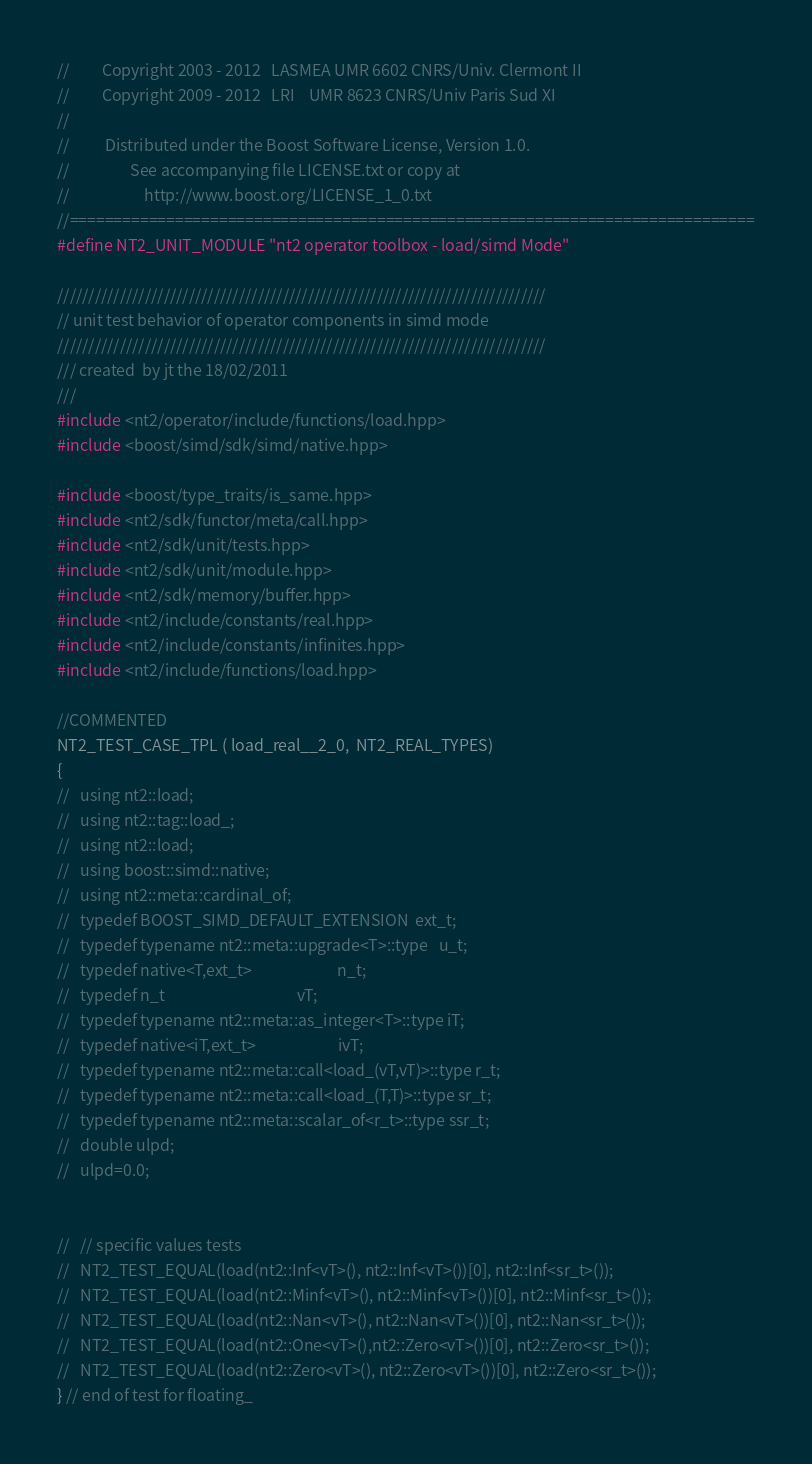<code> <loc_0><loc_0><loc_500><loc_500><_C++_>//         Copyright 2003 - 2012   LASMEA UMR 6602 CNRS/Univ. Clermont II
//         Copyright 2009 - 2012   LRI    UMR 8623 CNRS/Univ Paris Sud XI
//
//          Distributed under the Boost Software License, Version 1.0.
//                 See accompanying file LICENSE.txt or copy at
//                     http://www.boost.org/LICENSE_1_0.txt
//==============================================================================
#define NT2_UNIT_MODULE "nt2 operator toolbox - load/simd Mode"

//////////////////////////////////////////////////////////////////////////////
// unit test behavior of operator components in simd mode
//////////////////////////////////////////////////////////////////////////////
/// created  by jt the 18/02/2011
///
#include <nt2/operator/include/functions/load.hpp>
#include <boost/simd/sdk/simd/native.hpp>

#include <boost/type_traits/is_same.hpp>
#include <nt2/sdk/functor/meta/call.hpp>
#include <nt2/sdk/unit/tests.hpp>
#include <nt2/sdk/unit/module.hpp>
#include <nt2/sdk/memory/buffer.hpp>
#include <nt2/include/constants/real.hpp>
#include <nt2/include/constants/infinites.hpp>
#include <nt2/include/functions/load.hpp>

//COMMENTED
NT2_TEST_CASE_TPL ( load_real__2_0,  NT2_REAL_TYPES)
{
//   using nt2::load;
//   using nt2::tag::load_;
//   using nt2::load;
//   using boost::simd::native;
//   using nt2::meta::cardinal_of;
//   typedef BOOST_SIMD_DEFAULT_EXTENSION  ext_t;
//   typedef typename nt2::meta::upgrade<T>::type   u_t;
//   typedef native<T,ext_t>                        n_t;
//   typedef n_t                                     vT;
//   typedef typename nt2::meta::as_integer<T>::type iT;
//   typedef native<iT,ext_t>                       ivT;
//   typedef typename nt2::meta::call<load_(vT,vT)>::type r_t;
//   typedef typename nt2::meta::call<load_(T,T)>::type sr_t;
//   typedef typename nt2::meta::scalar_of<r_t>::type ssr_t;
//   double ulpd;
//   ulpd=0.0;


//   // specific values tests
//   NT2_TEST_EQUAL(load(nt2::Inf<vT>(), nt2::Inf<vT>())[0], nt2::Inf<sr_t>());
//   NT2_TEST_EQUAL(load(nt2::Minf<vT>(), nt2::Minf<vT>())[0], nt2::Minf<sr_t>());
//   NT2_TEST_EQUAL(load(nt2::Nan<vT>(), nt2::Nan<vT>())[0], nt2::Nan<sr_t>());
//   NT2_TEST_EQUAL(load(nt2::One<vT>(),nt2::Zero<vT>())[0], nt2::Zero<sr_t>());
//   NT2_TEST_EQUAL(load(nt2::Zero<vT>(), nt2::Zero<vT>())[0], nt2::Zero<sr_t>());
} // end of test for floating_
</code> 